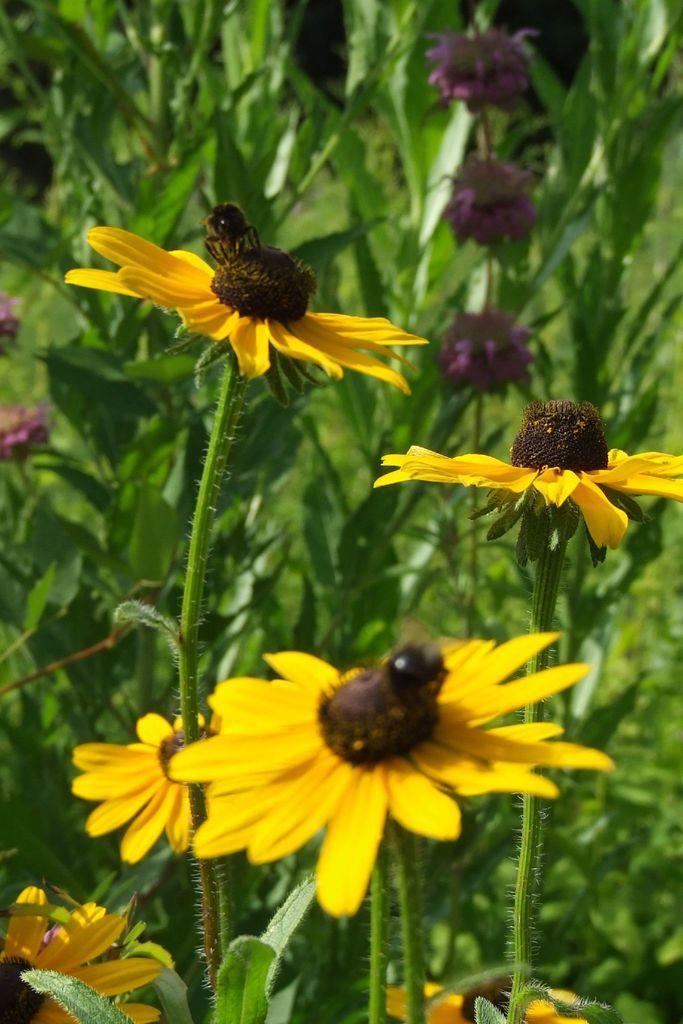Could you give a brief overview of what you see in this image? We can see flowers and plants. We can see insects on these flowers. 